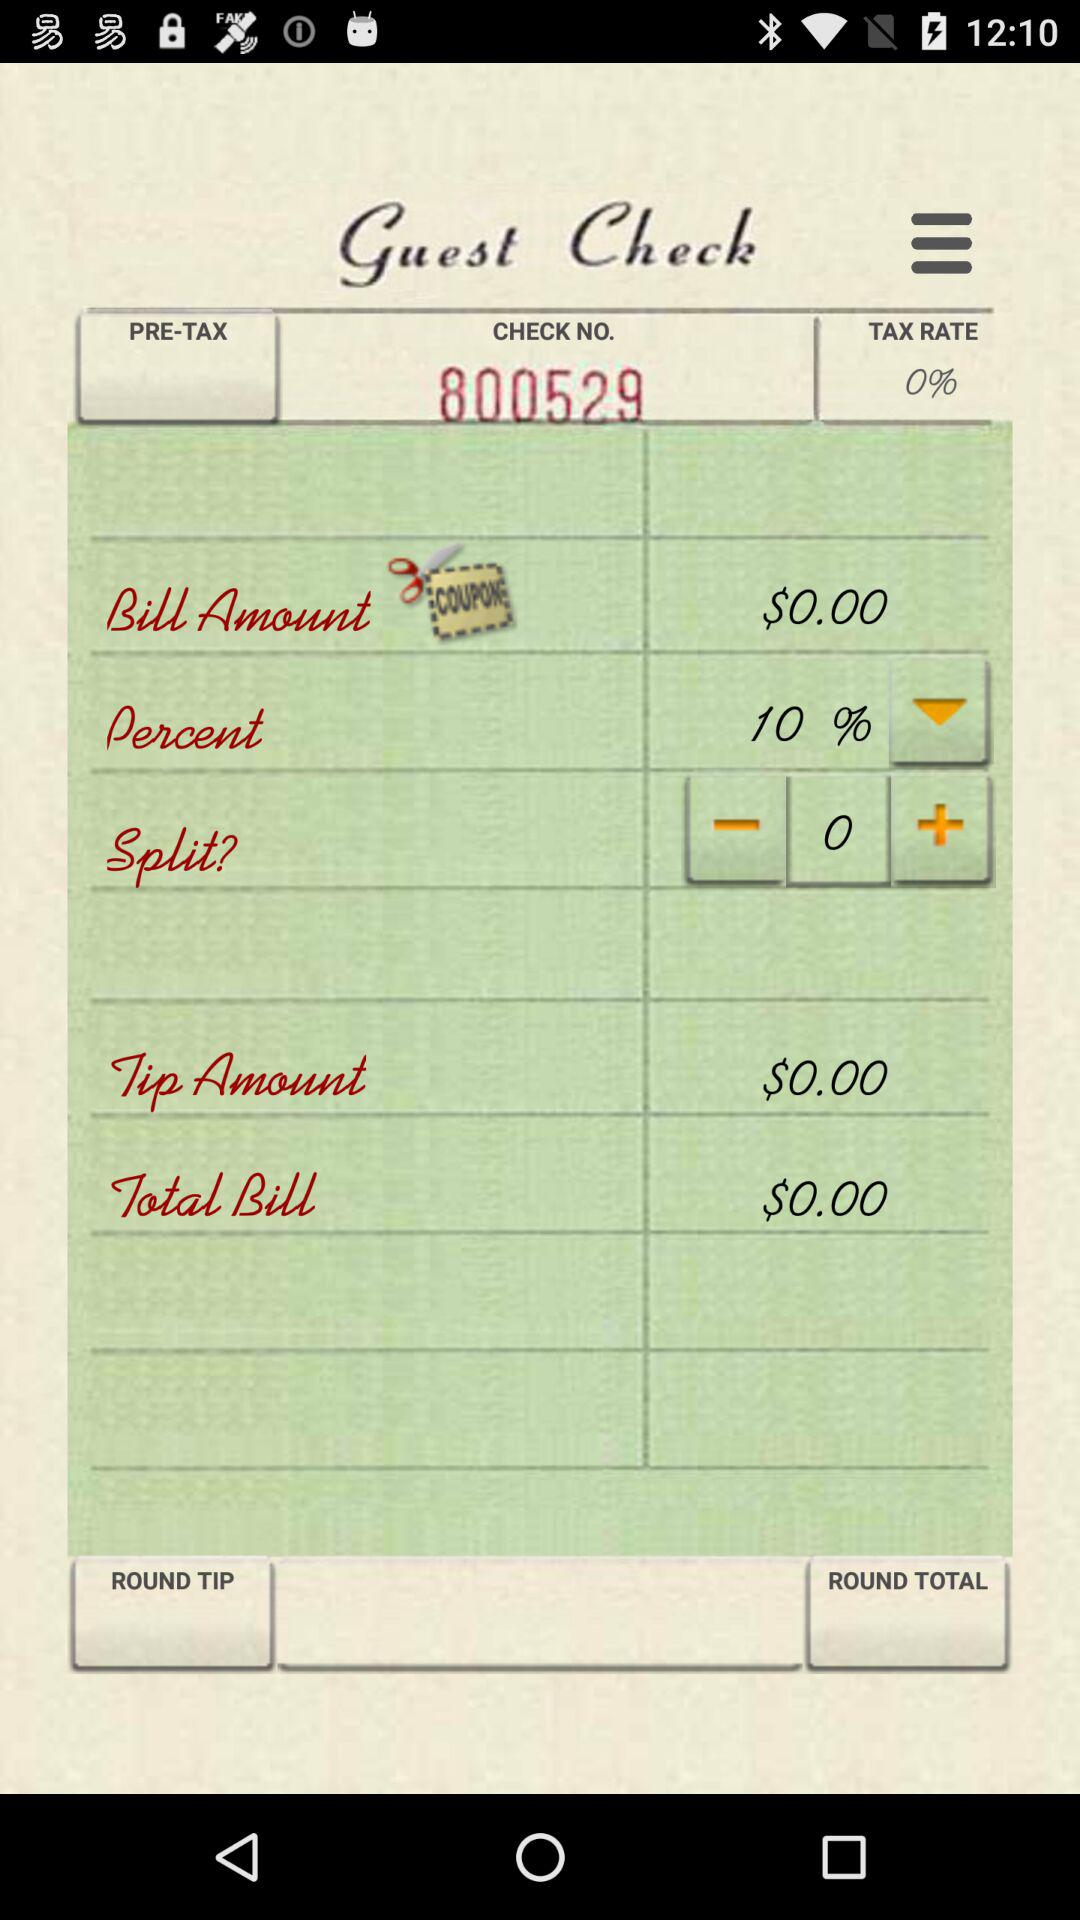How much is the tip amount? The tip amount is $0.00. 